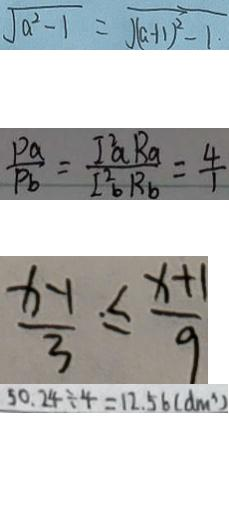Convert formula to latex. <formula><loc_0><loc_0><loc_500><loc_500>\sqrt { a ^ { 2 } - 1 } = \sqrt { ( a + 1 ) ^ { 2 } - 1 } 
 \frac { P a } { P b } = \frac { I ^ { 2 } a R _ { a } } { I _ { b } ^ { 2 } R _ { a } } = \frac { 4 } { 1 } 
 \frac { x - 1 } { 3 } \leq \frac { x + 1 } { 9 } 
 5 0 . 2 4 \div 4 = 1 2 . 5 6 ( d m ^ { 3 } )</formula> 